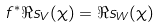<formula> <loc_0><loc_0><loc_500><loc_500>f ^ { * } \Re s _ { V } ( \chi ) = \Re s _ { W } ( \chi )</formula> 